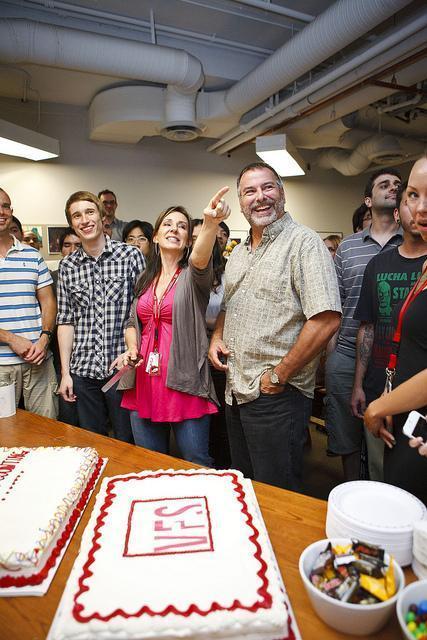How many people can you see?
Give a very brief answer. 8. How many cakes can you see?
Give a very brief answer. 2. How many suv cars are in the picture?
Give a very brief answer. 0. 